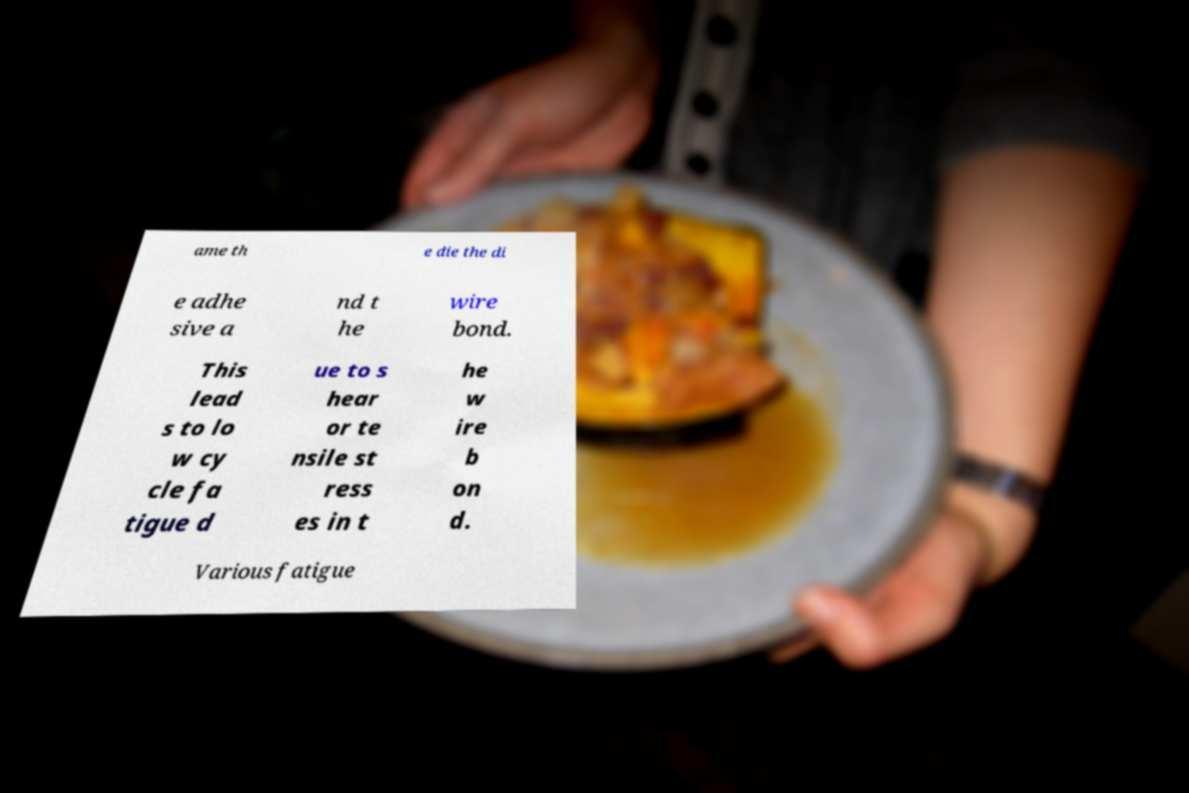Can you read and provide the text displayed in the image?This photo seems to have some interesting text. Can you extract and type it out for me? ame th e die the di e adhe sive a nd t he wire bond. This lead s to lo w cy cle fa tigue d ue to s hear or te nsile st ress es in t he w ire b on d. Various fatigue 